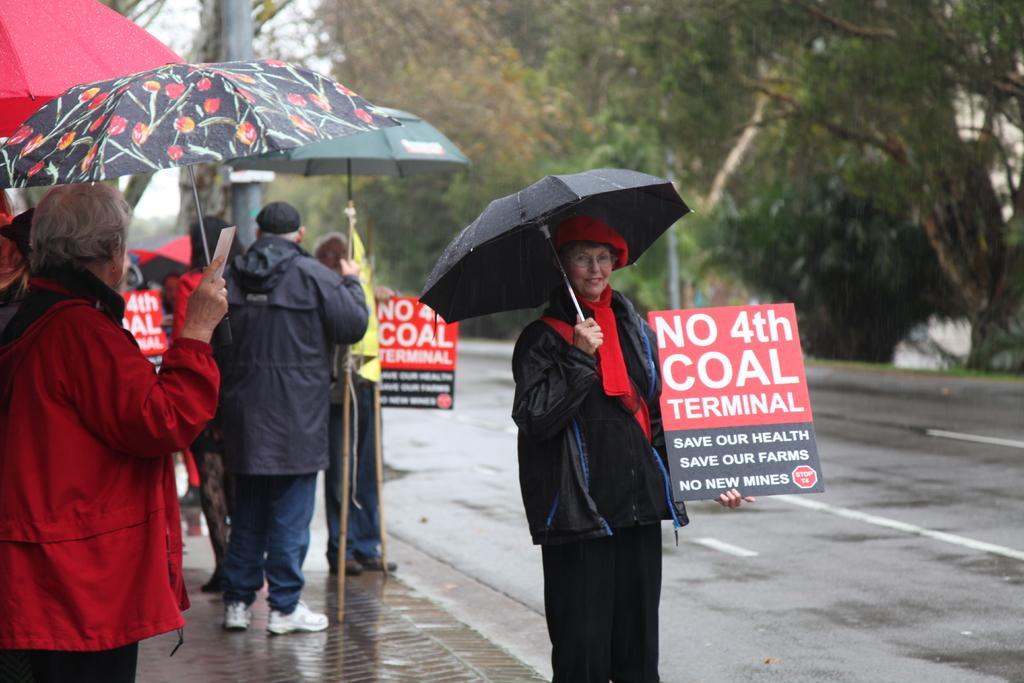In one or two sentences, can you explain what this image depicts? In the image there are few people in raincoats standing at the side of the road holding umbrella, it seems to be raining, the woman in the front holding a banner, on the right side there are trees on the side of the road. 